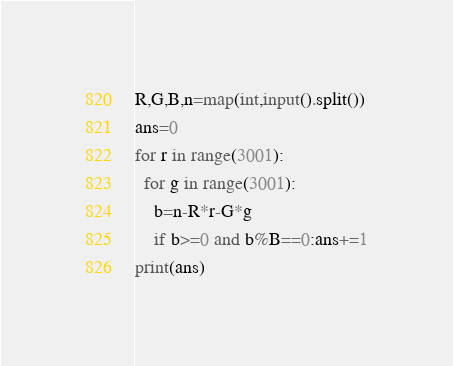<code> <loc_0><loc_0><loc_500><loc_500><_Python_>R,G,B,n=map(int,input().split())
ans=0
for r in range(3001):
  for g in range(3001):
    b=n-R*r-G*g
    if b>=0 and b%B==0:ans+=1
print(ans)
</code> 